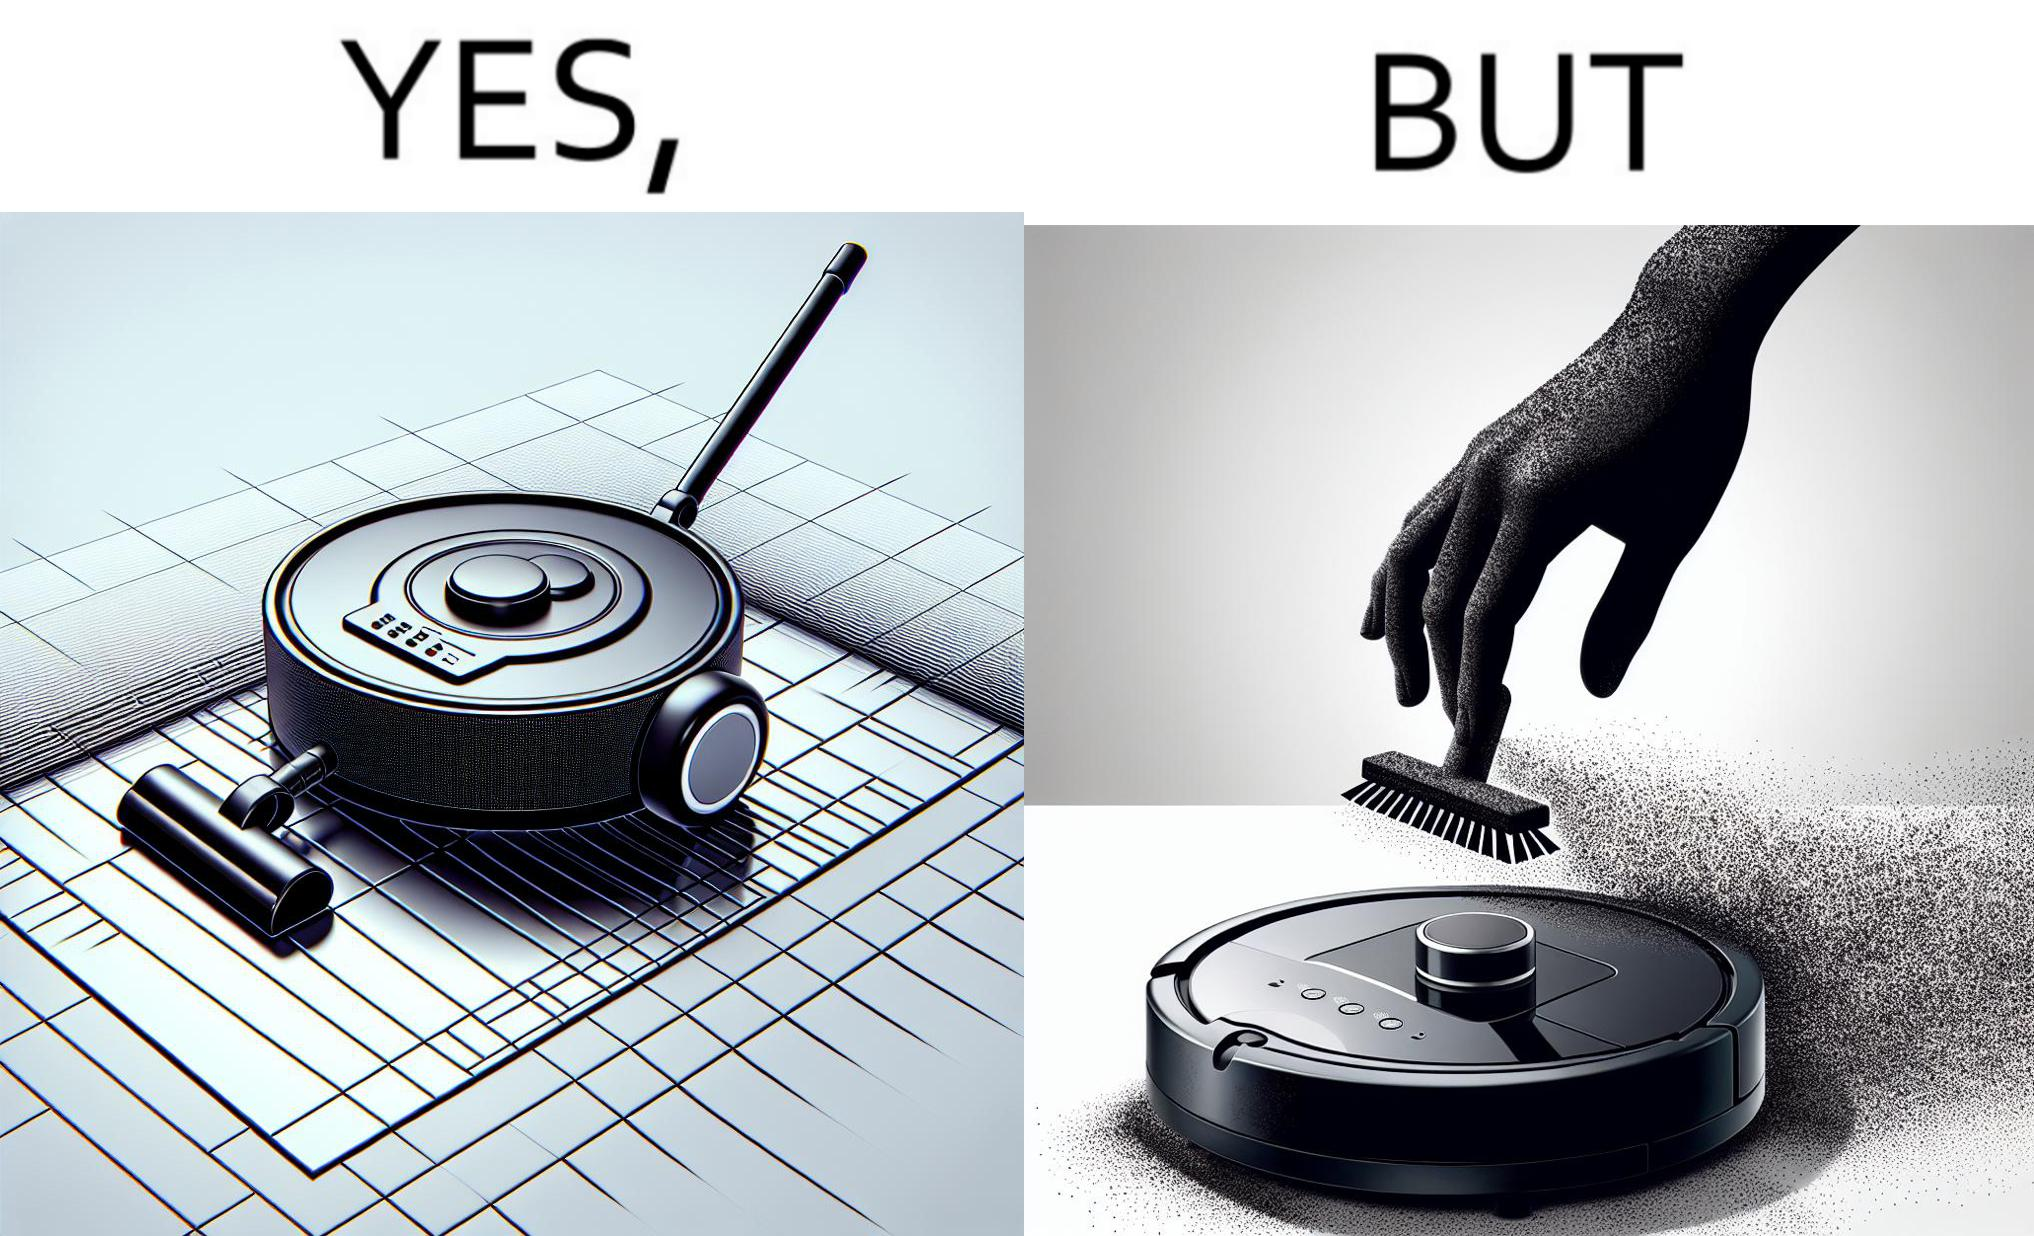What do you see in each half of this image? In the left part of the image: A vacuum cleaning machine that goes around the floor on its own and cleans the floor. Everything  around it looks squeaky clean, and is shining. In the right part of the image: Close up of a vacuum cleaning machine that goes around the floor on its own and cleans the floor. Everything  around it looks squeaky clean, and is shining, but it has a lot of dust on it except one line on it that looks clean. A persons fingertip is visible, and it is covered in dust. 